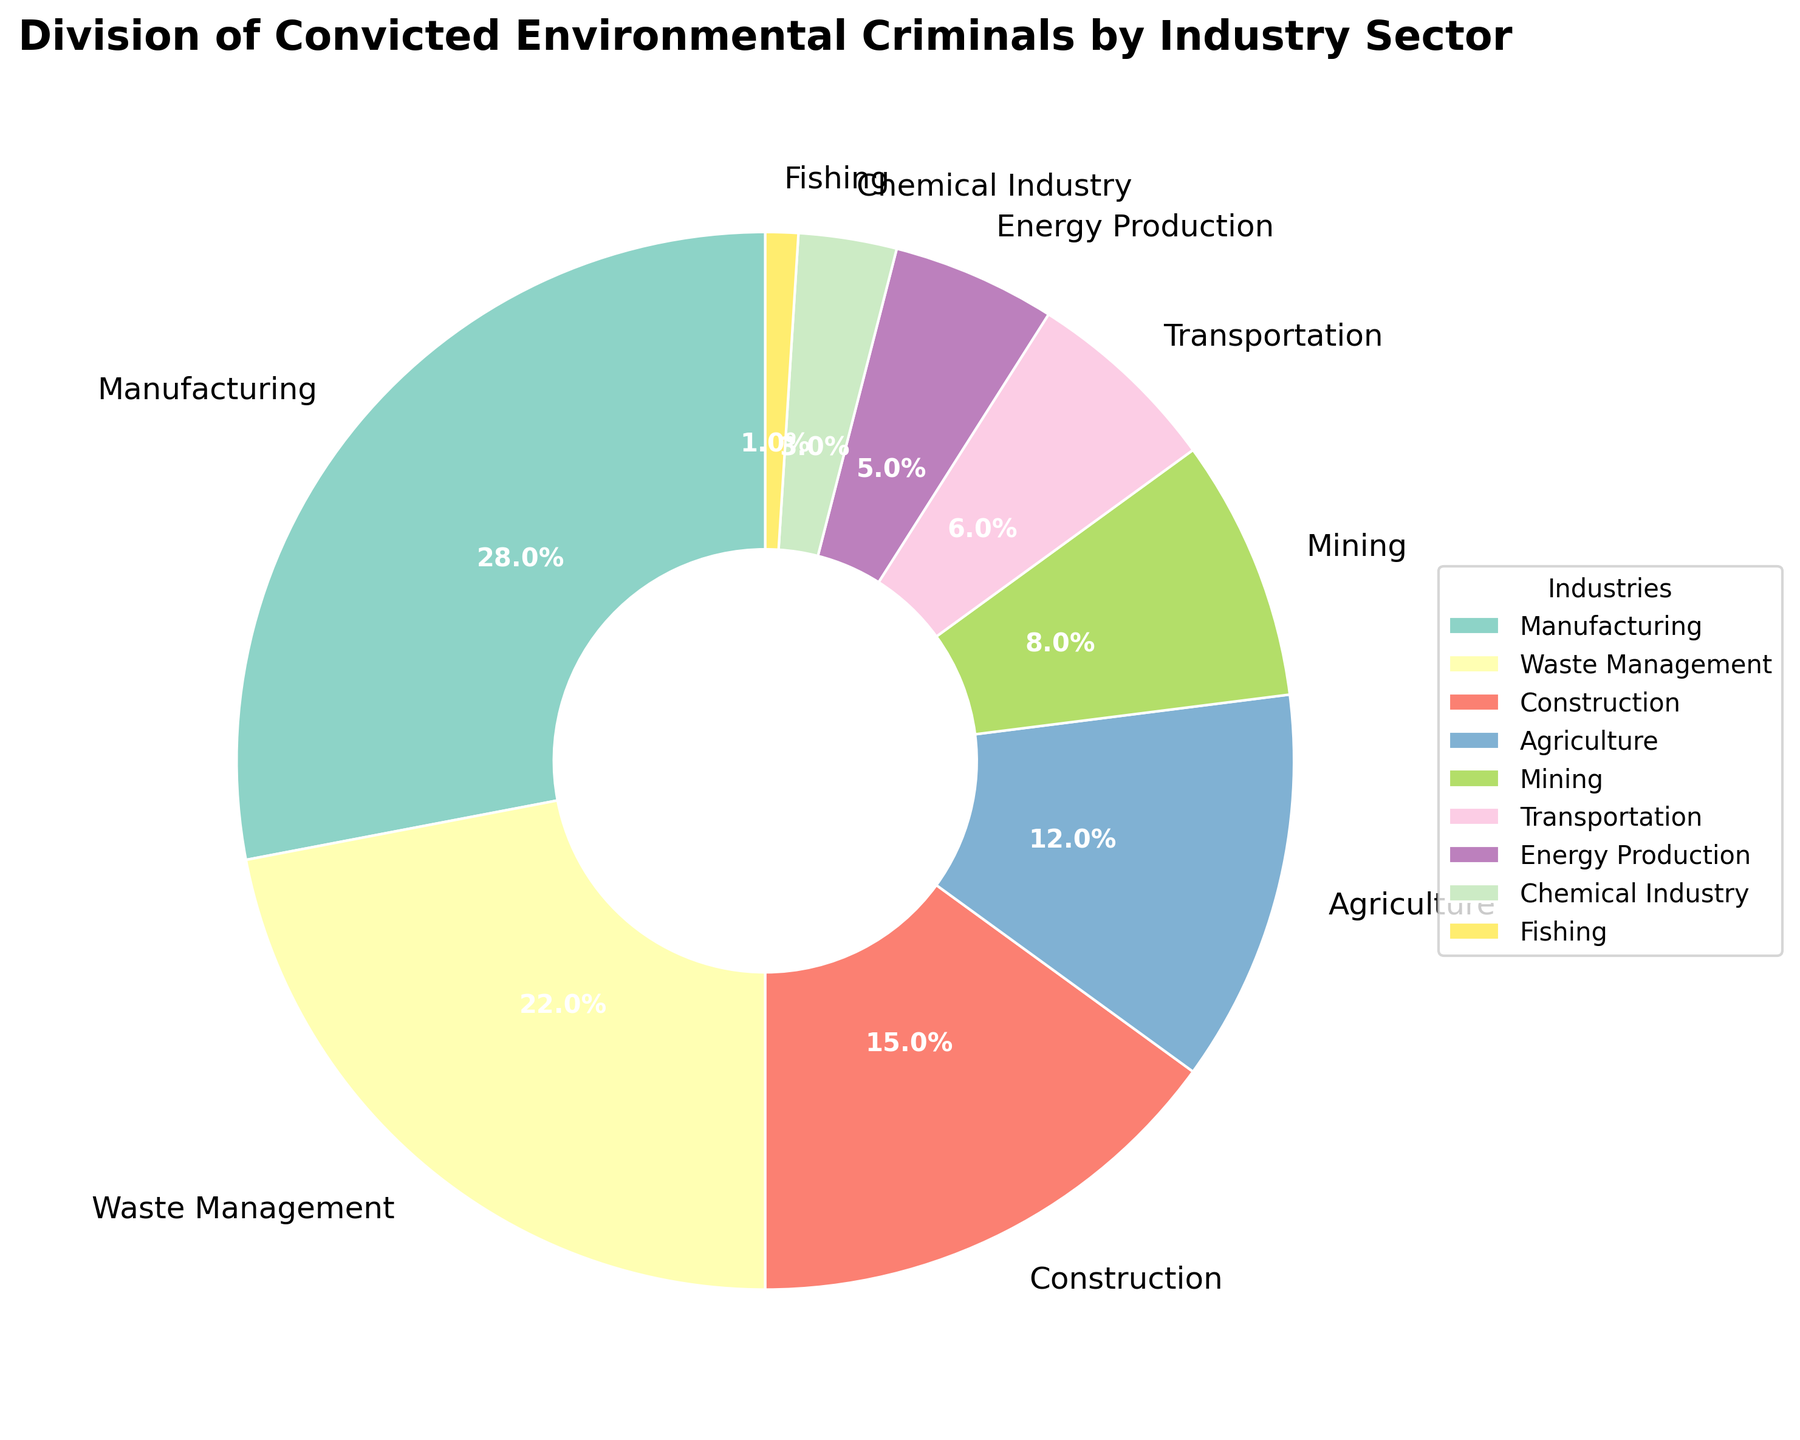What is the percentage of convicted criminals in the Manufacturing sector? The pie chart shows the percentage distribution of convicted environmental criminals by industry sector. Looking at the Manufacturing sector slice, the corresponding label shows 28%.
Answer: 28% Which sector has a higher percentage of convicted environmental criminals, Agriculture or Transportation? Comparing the slices labeled Agriculture (12%) and Transportation (6%), Agriculture has a higher percentage.
Answer: Agriculture What is the combined percentage of convicted criminals in the Manufacturing, Waste Management, and Construction sectors? Add the percentages from the Manufacturing (28%), Waste Management (22%), and Construction (15%) slices. The combined percentage is 28 + 22 + 15 = 65%.
Answer: 65% Which sector has the smallest percentage of convicted environmental criminals, and what is that percentage? The smallest slice in the pie chart is labeled Fishing and shows a percentage of 1%.
Answer: Fishing, 1% How do the percentages of the Mining and Energy Production sectors compare? By observing the slices for Mining (8%) and Energy Production (5%), it is clear that Mining has a higher percentage than Energy Production.
Answer: Mining has a higher percentage Calculate the difference in percentage points between Waste Management and Agriculture sectors. The Waste Management slice shows 22% and the Agriculture slice shows 12%. The difference is 22 - 12 = 10 percentage points.
Answer: 10 percentage points Which sectors combined make up more than 50% of the total convicted environmental criminals? The combined percentages of Manufacturing (28%) and Waste Management (22%) make up exactly 50%, while adding Construction (15%) brings the total to 65%. Therefore, Manufacturing, Waste Management, and Construction combined make up more than 50%.
Answer: Manufacturing, Waste Management, Construction What are the percentages of convicted criminals in all the sectors that have less than 10% each? The slices for sectors with less than 10% each are Mining (8%), Transportation (6%), Energy Production (5%), Chemical Industry (3%), and Fishing (1%).
Answer: Mining (8%), Transportation (6%), Energy Production (5%), Chemical Industry (3%), Fishing (1%) If you combine the percentages of Agriculture and Waste Management, does it exceed 30%? The Agriculture slice shows 12% and the Waste Management slice shows 22%. Combined, they have 12 + 22 = 34%, which exceeds 30%.
Answer: Yes, it exceeds 30% What is the color used for the Construction sector slice in the pie chart? By visually checking the pie chart, the Construction sector slice can be identified by its distinct color based on visual observation of the legend and the chart coloring scheme.
Answer: (Provide color based on visual observation) 